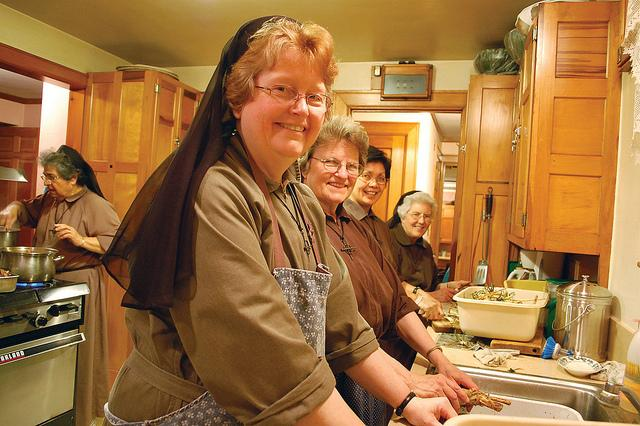What profession are these women in?

Choices:
A) nurses
B) cashiers
C) teachers
D) nuns nuns 